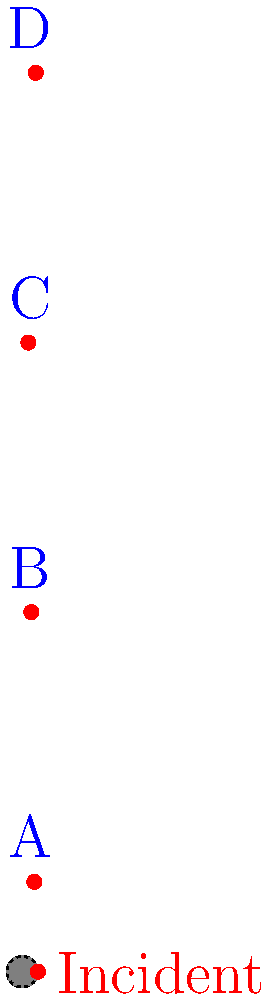A safety coordinator has plotted four workplace incidents on a polar grid, dividing the area into four quadrants (A, B, C, and D). Based on the diagram, in which quadrant did the majority of incidents occur? To determine the quadrant with the majority of incidents, we need to count the number of incidents in each quadrant:

1. Quadrant A (top-right): 1 incident
2. Quadrant B (top-left): 1 incident
3. Quadrant C (bottom-left): 1 incident
4. Quadrant D (bottom-right): 1 incident

We can see that:
- The incident at $(r, \theta) \approx (4, 30°)$ is in quadrant A.
- The incident at $(r, \theta) \approx (3, 120°)$ is in quadrant B.
- The incident at $(r, \theta) \approx (2, 210°)$ is in quadrant C.
- The incident at $(r, \theta) \approx (4.5, 300°)$ is in quadrant D.

Each quadrant has exactly one incident, so there is no single quadrant with a majority of incidents. The incidents are evenly distributed across all quadrants.
Answer: No single quadrant; incidents are evenly distributed. 